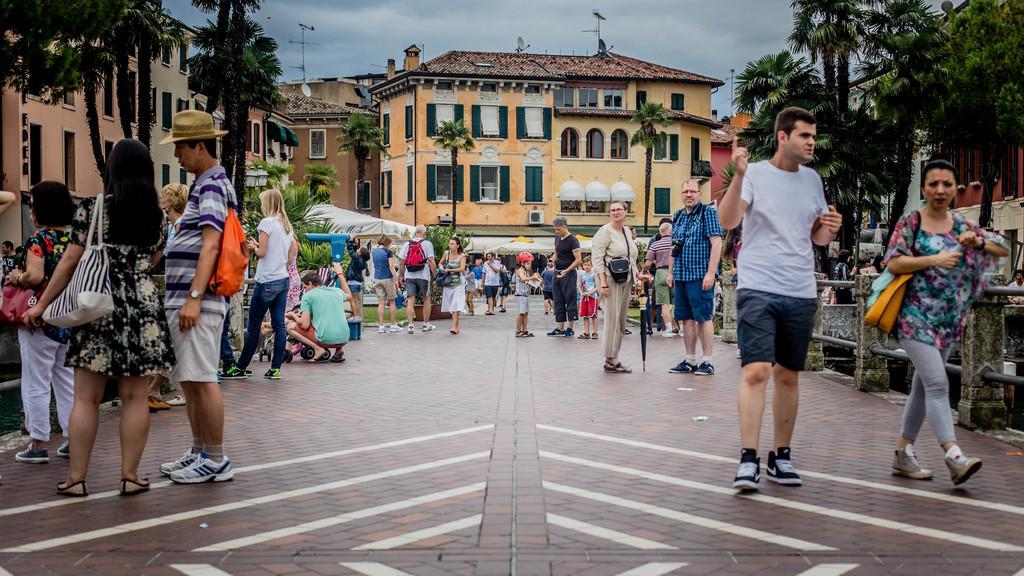Could you give a brief overview of what you see in this image? In the picture we can see group of people standing and some are walking along the floor and in the background of the picture there are some trees, buildings and top of the picture there is cloudy sky. 